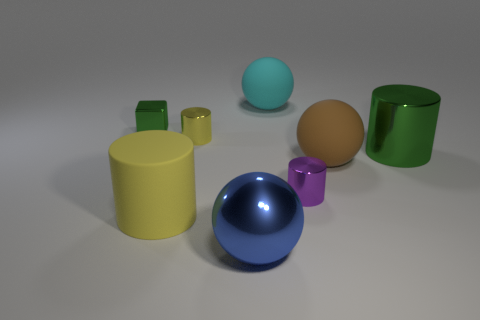What is the color of the large object in front of the yellow cylinder in front of the large metallic object to the right of the small purple cylinder?
Your answer should be very brief. Blue. Is the number of tiny purple metallic cylinders that are to the left of the big yellow matte object less than the number of large matte things behind the tiny green shiny block?
Ensure brevity in your answer.  Yes. Is the shape of the tiny yellow metal object the same as the cyan thing?
Your answer should be compact. No. How many brown objects have the same size as the brown sphere?
Your answer should be very brief. 0. Are there fewer purple cylinders in front of the metallic cube than rubber balls?
Offer a terse response. Yes. There is a shiny object that is in front of the small object right of the tiny yellow cylinder; what is its size?
Make the answer very short. Large. How many objects are purple metal cylinders or brown matte balls?
Make the answer very short. 2. Is there a large shiny cylinder that has the same color as the tiny block?
Ensure brevity in your answer.  Yes. Are there fewer big metal objects than objects?
Keep it short and to the point. Yes. What number of things are large purple rubber cylinders or large rubber things to the left of the large cyan rubber thing?
Offer a terse response. 1. 